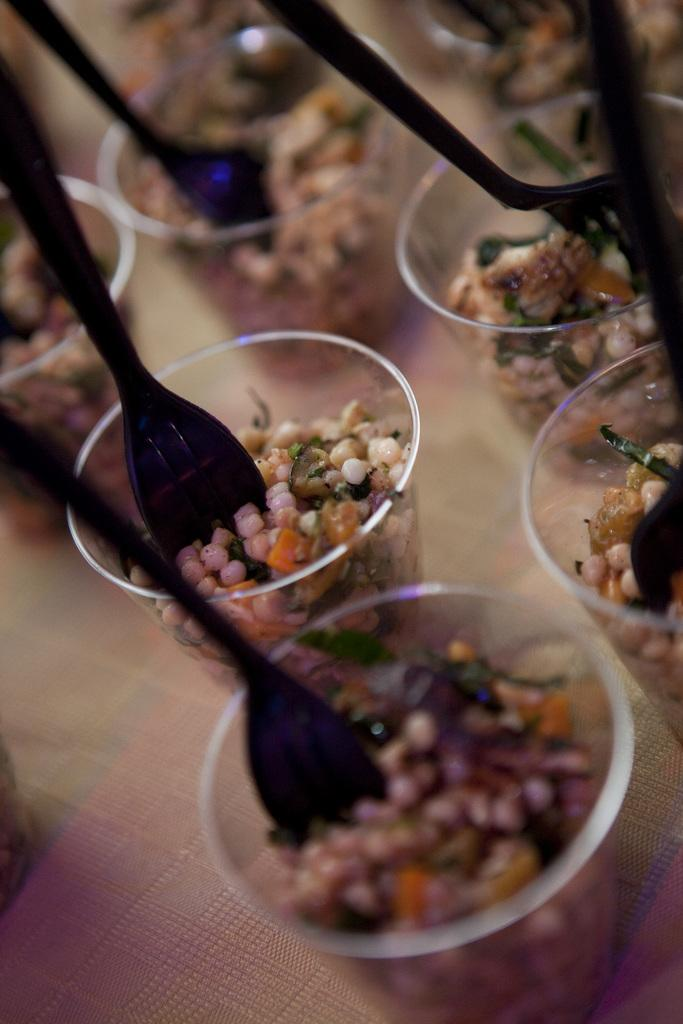What is inside the glasses that are visible in the image? There are glasses containing food or eatables in the image. What utensils are present in the image? Spoons are visible in the image. Where are the glasses and spoons located? The glasses and spoons are placed on a table. Can you describe the background of the image? The background of the image is blurred. What type of books can be seen in the image? There are no books present in the image. What story is being told in the image? The image does not depict a story; it shows glasses containing food or eatables and spoons on a table. 